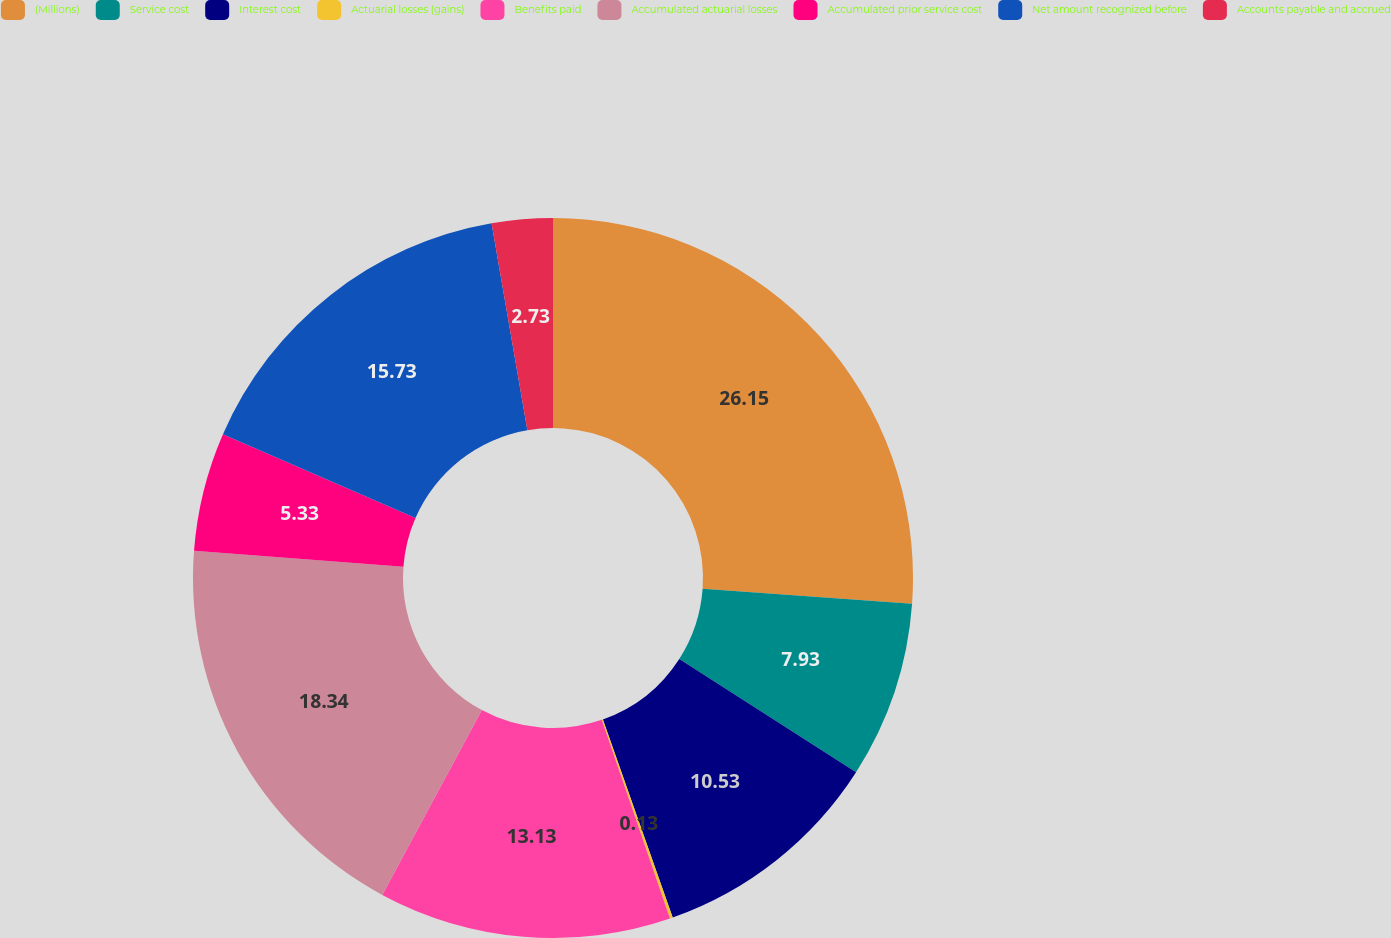Convert chart to OTSL. <chart><loc_0><loc_0><loc_500><loc_500><pie_chart><fcel>(Millions)<fcel>Service cost<fcel>Interest cost<fcel>Actuarial losses (gains)<fcel>Benefits paid<fcel>Accumulated actuarial losses<fcel>Accumulated prior service cost<fcel>Net amount recognized before<fcel>Accounts payable and accrued<nl><fcel>26.14%<fcel>7.93%<fcel>10.53%<fcel>0.13%<fcel>13.13%<fcel>18.34%<fcel>5.33%<fcel>15.73%<fcel>2.73%<nl></chart> 